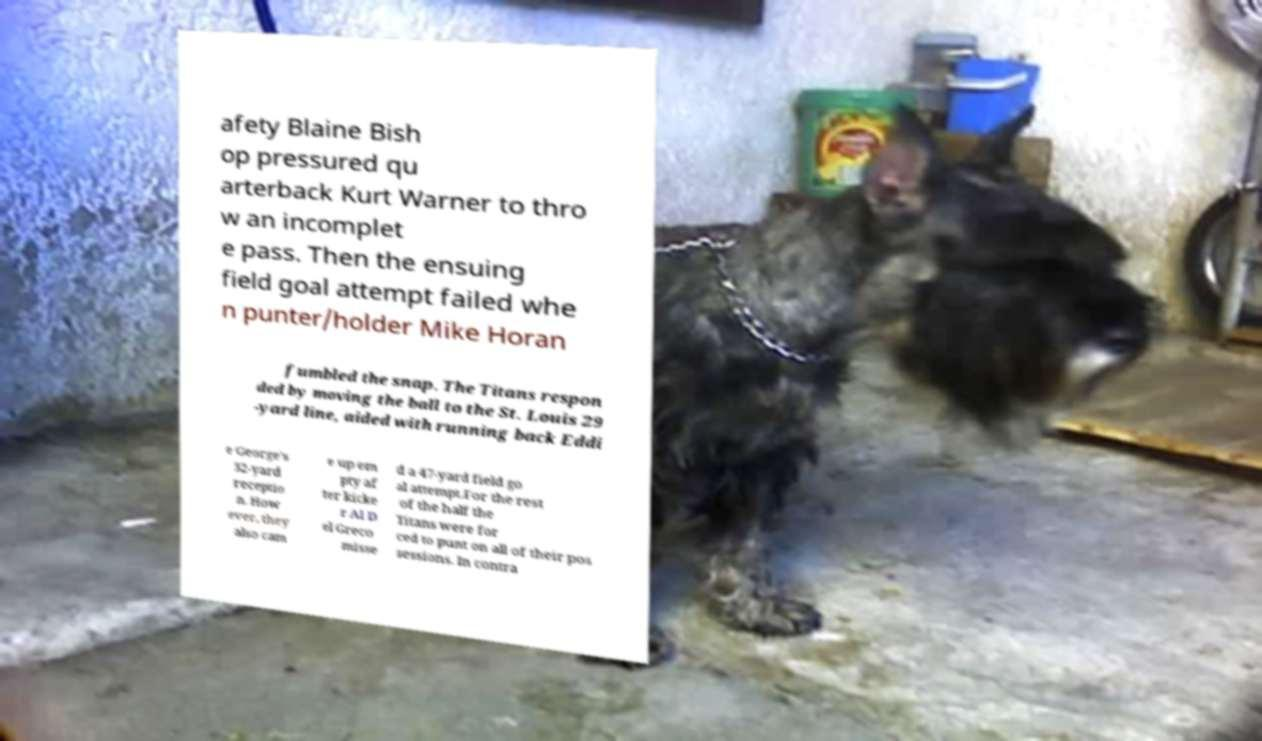Please read and relay the text visible in this image. What does it say? afety Blaine Bish op pressured qu arterback Kurt Warner to thro w an incomplet e pass. Then the ensuing field goal attempt failed whe n punter/holder Mike Horan fumbled the snap. The Titans respon ded by moving the ball to the St. Louis 29 -yard line, aided with running back Eddi e George's 32-yard receptio n. How ever, they also cam e up em pty af ter kicke r Al D el Greco misse d a 47-yard field go al attempt.For the rest of the half the Titans were for ced to punt on all of their pos sessions. In contra 